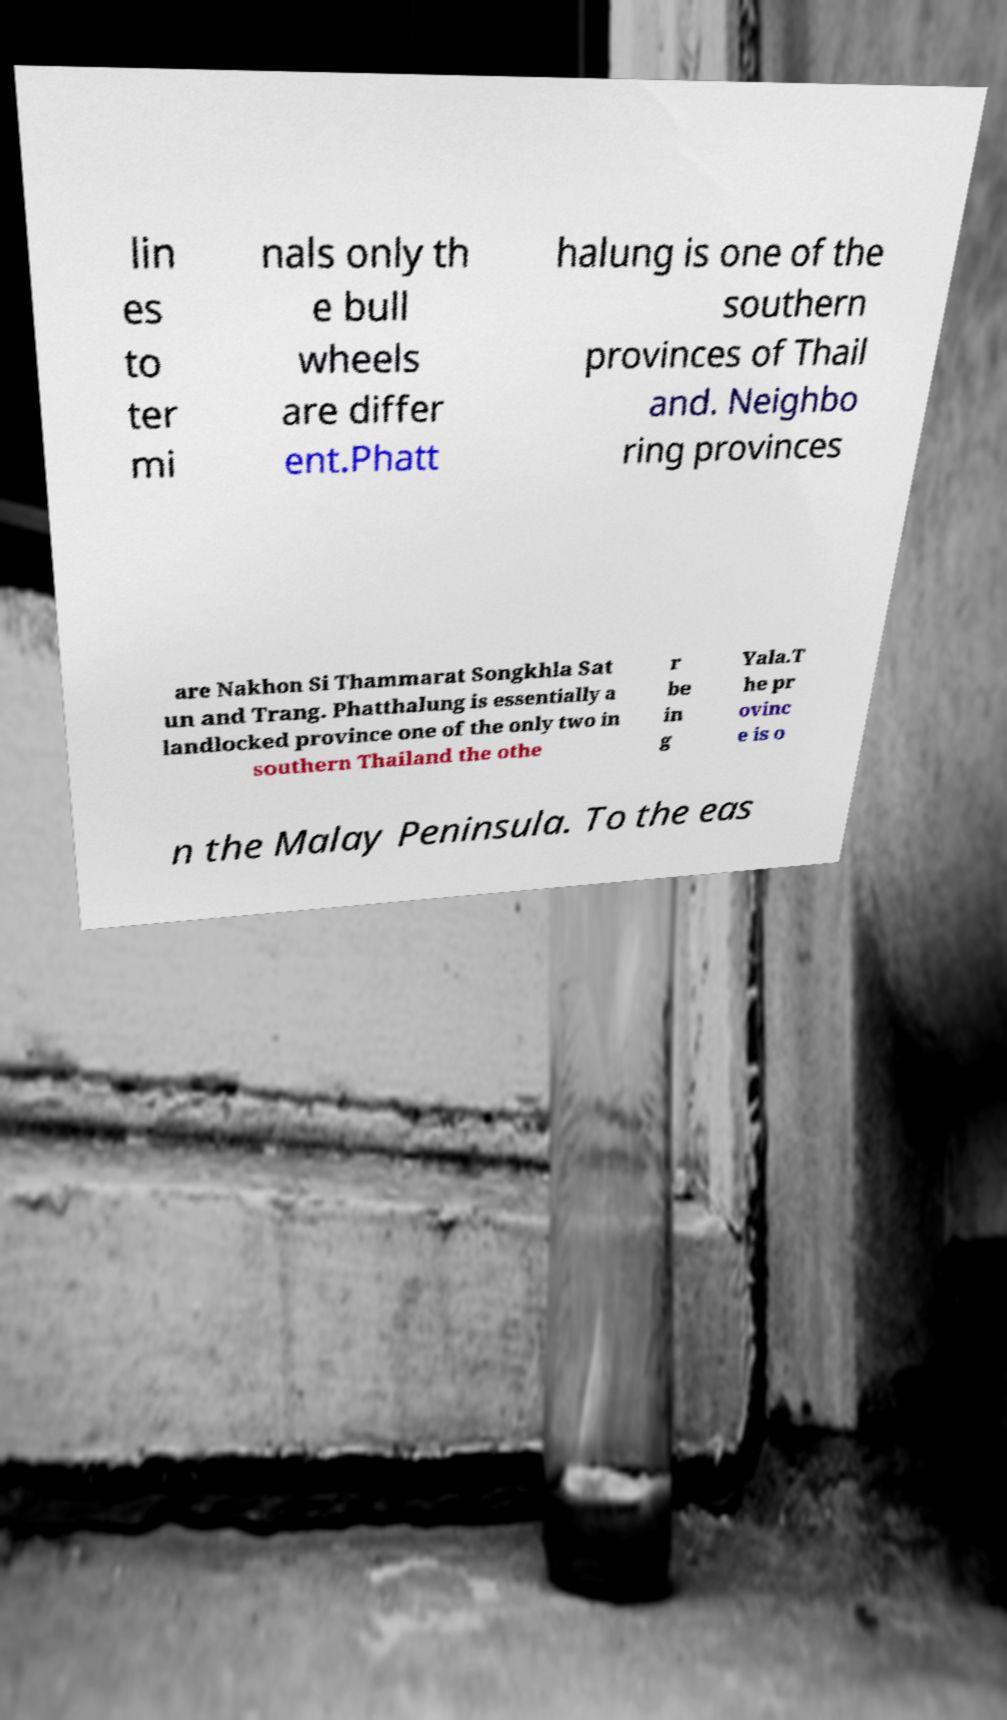What messages or text are displayed in this image? I need them in a readable, typed format. lin es to ter mi nals only th e bull wheels are differ ent.Phatt halung is one of the southern provinces of Thail and. Neighbo ring provinces are Nakhon Si Thammarat Songkhla Sat un and Trang. Phatthalung is essentially a landlocked province one of the only two in southern Thailand the othe r be in g Yala.T he pr ovinc e is o n the Malay Peninsula. To the eas 